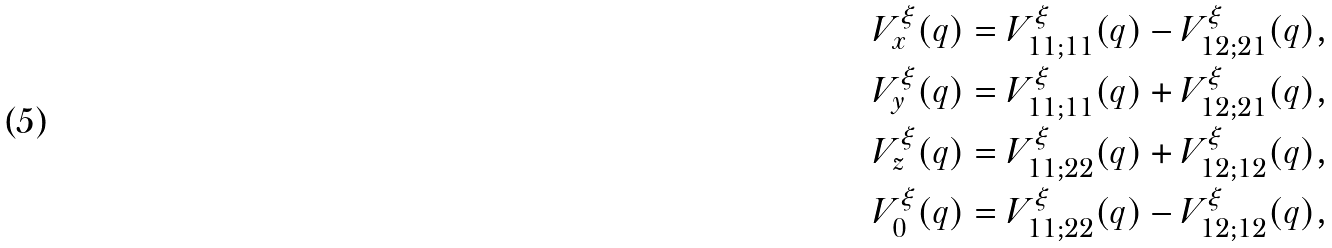<formula> <loc_0><loc_0><loc_500><loc_500>V ^ { \xi } _ { x } ( q ) = V ^ { \xi } _ { 1 1 ; 1 1 } ( q ) - V ^ { \xi } _ { 1 2 ; 2 1 } ( q ) , \\ V ^ { \xi } _ { y } ( q ) = V ^ { \xi } _ { 1 1 ; 1 1 } ( q ) + V ^ { \xi } _ { 1 2 ; 2 1 } ( q ) , \\ V ^ { \xi } _ { z } ( q ) = V ^ { \xi } _ { 1 1 ; 2 2 } ( q ) + V ^ { \xi } _ { 1 2 ; 1 2 } ( q ) , \\ V ^ { \xi } _ { 0 } ( q ) = V ^ { \xi } _ { 1 1 ; 2 2 } ( q ) - V ^ { \xi } _ { 1 2 ; 1 2 } ( q ) ,</formula> 